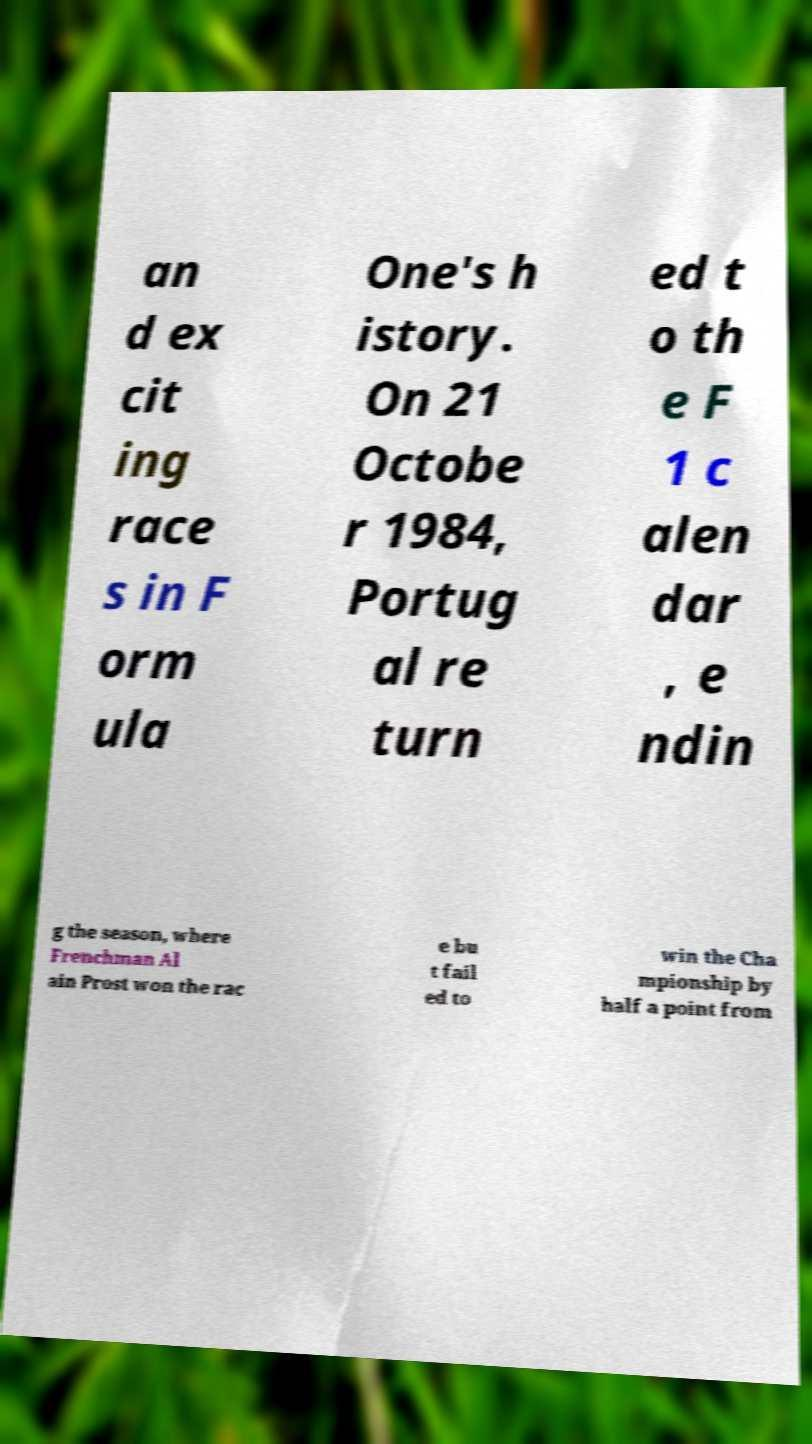Please identify and transcribe the text found in this image. an d ex cit ing race s in F orm ula One's h istory. On 21 Octobe r 1984, Portug al re turn ed t o th e F 1 c alen dar , e ndin g the season, where Frenchman Al ain Prost won the rac e bu t fail ed to win the Cha mpionship by half a point from 